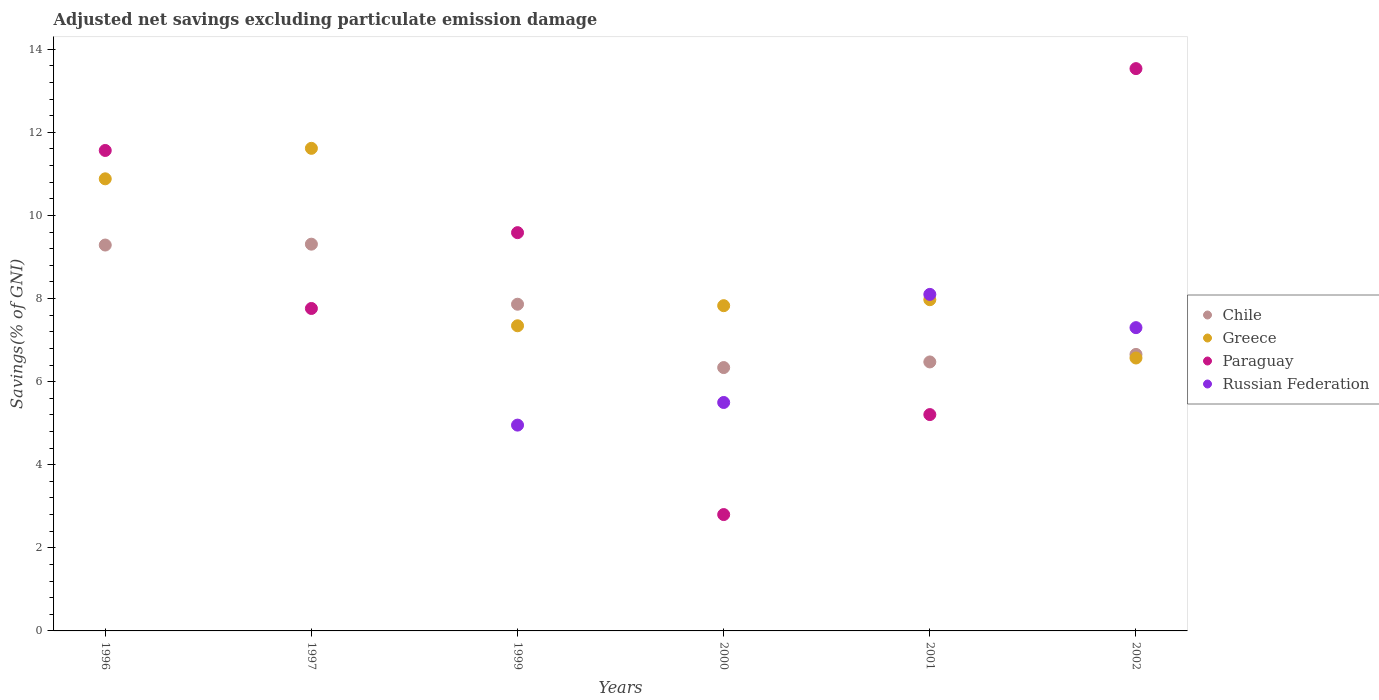Is the number of dotlines equal to the number of legend labels?
Keep it short and to the point. No. What is the adjusted net savings in Paraguay in 2000?
Your response must be concise. 2.8. Across all years, what is the maximum adjusted net savings in Paraguay?
Your answer should be very brief. 13.53. Across all years, what is the minimum adjusted net savings in Russian Federation?
Make the answer very short. 0. What is the total adjusted net savings in Greece in the graph?
Keep it short and to the point. 52.21. What is the difference between the adjusted net savings in Paraguay in 1996 and that in 2000?
Your answer should be very brief. 8.76. What is the difference between the adjusted net savings in Russian Federation in 1997 and the adjusted net savings in Chile in 2000?
Give a very brief answer. -6.34. What is the average adjusted net savings in Chile per year?
Make the answer very short. 7.65. In the year 1997, what is the difference between the adjusted net savings in Paraguay and adjusted net savings in Greece?
Your answer should be very brief. -3.85. What is the ratio of the adjusted net savings in Chile in 1996 to that in 1999?
Give a very brief answer. 1.18. Is the adjusted net savings in Paraguay in 1996 less than that in 2000?
Ensure brevity in your answer.  No. Is the difference between the adjusted net savings in Paraguay in 1997 and 2002 greater than the difference between the adjusted net savings in Greece in 1997 and 2002?
Give a very brief answer. No. What is the difference between the highest and the second highest adjusted net savings in Russian Federation?
Your answer should be compact. 0.8. What is the difference between the highest and the lowest adjusted net savings in Russian Federation?
Provide a short and direct response. 8.1. In how many years, is the adjusted net savings in Russian Federation greater than the average adjusted net savings in Russian Federation taken over all years?
Offer a very short reply. 4. Is the sum of the adjusted net savings in Paraguay in 1996 and 1997 greater than the maximum adjusted net savings in Greece across all years?
Your answer should be compact. Yes. Does the adjusted net savings in Chile monotonically increase over the years?
Ensure brevity in your answer.  No. Is the adjusted net savings in Chile strictly greater than the adjusted net savings in Greece over the years?
Make the answer very short. No. Is the adjusted net savings in Paraguay strictly less than the adjusted net savings in Chile over the years?
Your answer should be compact. No. How many dotlines are there?
Your answer should be very brief. 4. What is the difference between two consecutive major ticks on the Y-axis?
Offer a terse response. 2. Are the values on the major ticks of Y-axis written in scientific E-notation?
Offer a terse response. No. Does the graph contain any zero values?
Your answer should be very brief. Yes. Does the graph contain grids?
Your answer should be compact. No. Where does the legend appear in the graph?
Make the answer very short. Center right. How many legend labels are there?
Offer a terse response. 4. What is the title of the graph?
Keep it short and to the point. Adjusted net savings excluding particulate emission damage. Does "Bulgaria" appear as one of the legend labels in the graph?
Provide a short and direct response. No. What is the label or title of the Y-axis?
Your response must be concise. Savings(% of GNI). What is the Savings(% of GNI) of Chile in 1996?
Provide a short and direct response. 9.29. What is the Savings(% of GNI) in Greece in 1996?
Offer a terse response. 10.88. What is the Savings(% of GNI) in Paraguay in 1996?
Give a very brief answer. 11.56. What is the Savings(% of GNI) of Russian Federation in 1996?
Make the answer very short. 0. What is the Savings(% of GNI) of Chile in 1997?
Make the answer very short. 9.31. What is the Savings(% of GNI) of Greece in 1997?
Provide a succinct answer. 11.62. What is the Savings(% of GNI) of Paraguay in 1997?
Your response must be concise. 7.76. What is the Savings(% of GNI) in Russian Federation in 1997?
Ensure brevity in your answer.  0. What is the Savings(% of GNI) in Chile in 1999?
Give a very brief answer. 7.86. What is the Savings(% of GNI) of Greece in 1999?
Offer a terse response. 7.34. What is the Savings(% of GNI) in Paraguay in 1999?
Your answer should be very brief. 9.59. What is the Savings(% of GNI) in Russian Federation in 1999?
Your response must be concise. 4.95. What is the Savings(% of GNI) of Chile in 2000?
Provide a short and direct response. 6.34. What is the Savings(% of GNI) of Greece in 2000?
Make the answer very short. 7.83. What is the Savings(% of GNI) of Paraguay in 2000?
Keep it short and to the point. 2.8. What is the Savings(% of GNI) in Russian Federation in 2000?
Offer a terse response. 5.5. What is the Savings(% of GNI) in Chile in 2001?
Offer a very short reply. 6.47. What is the Savings(% of GNI) of Greece in 2001?
Give a very brief answer. 7.97. What is the Savings(% of GNI) of Paraguay in 2001?
Provide a short and direct response. 5.21. What is the Savings(% of GNI) of Russian Federation in 2001?
Your answer should be compact. 8.1. What is the Savings(% of GNI) in Chile in 2002?
Give a very brief answer. 6.66. What is the Savings(% of GNI) in Greece in 2002?
Offer a terse response. 6.57. What is the Savings(% of GNI) in Paraguay in 2002?
Offer a terse response. 13.53. What is the Savings(% of GNI) in Russian Federation in 2002?
Your answer should be compact. 7.3. Across all years, what is the maximum Savings(% of GNI) in Chile?
Keep it short and to the point. 9.31. Across all years, what is the maximum Savings(% of GNI) of Greece?
Your answer should be very brief. 11.62. Across all years, what is the maximum Savings(% of GNI) in Paraguay?
Your answer should be compact. 13.53. Across all years, what is the maximum Savings(% of GNI) of Russian Federation?
Provide a short and direct response. 8.1. Across all years, what is the minimum Savings(% of GNI) of Chile?
Offer a terse response. 6.34. Across all years, what is the minimum Savings(% of GNI) of Greece?
Ensure brevity in your answer.  6.57. Across all years, what is the minimum Savings(% of GNI) in Paraguay?
Provide a succinct answer. 2.8. What is the total Savings(% of GNI) of Chile in the graph?
Keep it short and to the point. 45.93. What is the total Savings(% of GNI) of Greece in the graph?
Make the answer very short. 52.21. What is the total Savings(% of GNI) of Paraguay in the graph?
Keep it short and to the point. 50.45. What is the total Savings(% of GNI) of Russian Federation in the graph?
Give a very brief answer. 25.85. What is the difference between the Savings(% of GNI) in Chile in 1996 and that in 1997?
Offer a terse response. -0.02. What is the difference between the Savings(% of GNI) of Greece in 1996 and that in 1997?
Offer a very short reply. -0.73. What is the difference between the Savings(% of GNI) of Paraguay in 1996 and that in 1997?
Make the answer very short. 3.8. What is the difference between the Savings(% of GNI) of Chile in 1996 and that in 1999?
Your response must be concise. 1.42. What is the difference between the Savings(% of GNI) in Greece in 1996 and that in 1999?
Offer a very short reply. 3.54. What is the difference between the Savings(% of GNI) in Paraguay in 1996 and that in 1999?
Offer a terse response. 1.98. What is the difference between the Savings(% of GNI) in Chile in 1996 and that in 2000?
Give a very brief answer. 2.95. What is the difference between the Savings(% of GNI) of Greece in 1996 and that in 2000?
Keep it short and to the point. 3.05. What is the difference between the Savings(% of GNI) of Paraguay in 1996 and that in 2000?
Give a very brief answer. 8.76. What is the difference between the Savings(% of GNI) in Chile in 1996 and that in 2001?
Your answer should be very brief. 2.81. What is the difference between the Savings(% of GNI) in Greece in 1996 and that in 2001?
Offer a very short reply. 2.91. What is the difference between the Savings(% of GNI) of Paraguay in 1996 and that in 2001?
Offer a very short reply. 6.36. What is the difference between the Savings(% of GNI) of Chile in 1996 and that in 2002?
Give a very brief answer. 2.63. What is the difference between the Savings(% of GNI) of Greece in 1996 and that in 2002?
Your answer should be compact. 4.31. What is the difference between the Savings(% of GNI) of Paraguay in 1996 and that in 2002?
Your response must be concise. -1.97. What is the difference between the Savings(% of GNI) in Chile in 1997 and that in 1999?
Give a very brief answer. 1.45. What is the difference between the Savings(% of GNI) of Greece in 1997 and that in 1999?
Keep it short and to the point. 4.27. What is the difference between the Savings(% of GNI) in Paraguay in 1997 and that in 1999?
Give a very brief answer. -1.83. What is the difference between the Savings(% of GNI) of Chile in 1997 and that in 2000?
Provide a short and direct response. 2.97. What is the difference between the Savings(% of GNI) in Greece in 1997 and that in 2000?
Offer a terse response. 3.79. What is the difference between the Savings(% of GNI) in Paraguay in 1997 and that in 2000?
Make the answer very short. 4.96. What is the difference between the Savings(% of GNI) of Chile in 1997 and that in 2001?
Provide a short and direct response. 2.83. What is the difference between the Savings(% of GNI) of Greece in 1997 and that in 2001?
Provide a short and direct response. 3.64. What is the difference between the Savings(% of GNI) in Paraguay in 1997 and that in 2001?
Provide a short and direct response. 2.55. What is the difference between the Savings(% of GNI) of Chile in 1997 and that in 2002?
Give a very brief answer. 2.65. What is the difference between the Savings(% of GNI) of Greece in 1997 and that in 2002?
Your response must be concise. 5.05. What is the difference between the Savings(% of GNI) in Paraguay in 1997 and that in 2002?
Offer a terse response. -5.77. What is the difference between the Savings(% of GNI) in Chile in 1999 and that in 2000?
Provide a short and direct response. 1.52. What is the difference between the Savings(% of GNI) of Greece in 1999 and that in 2000?
Ensure brevity in your answer.  -0.48. What is the difference between the Savings(% of GNI) in Paraguay in 1999 and that in 2000?
Your answer should be compact. 6.79. What is the difference between the Savings(% of GNI) of Russian Federation in 1999 and that in 2000?
Your answer should be compact. -0.54. What is the difference between the Savings(% of GNI) in Chile in 1999 and that in 2001?
Offer a very short reply. 1.39. What is the difference between the Savings(% of GNI) in Greece in 1999 and that in 2001?
Offer a very short reply. -0.63. What is the difference between the Savings(% of GNI) of Paraguay in 1999 and that in 2001?
Your response must be concise. 4.38. What is the difference between the Savings(% of GNI) of Russian Federation in 1999 and that in 2001?
Your response must be concise. -3.15. What is the difference between the Savings(% of GNI) in Chile in 1999 and that in 2002?
Offer a very short reply. 1.21. What is the difference between the Savings(% of GNI) in Greece in 1999 and that in 2002?
Your answer should be very brief. 0.78. What is the difference between the Savings(% of GNI) in Paraguay in 1999 and that in 2002?
Keep it short and to the point. -3.95. What is the difference between the Savings(% of GNI) in Russian Federation in 1999 and that in 2002?
Make the answer very short. -2.35. What is the difference between the Savings(% of GNI) in Chile in 2000 and that in 2001?
Offer a very short reply. -0.14. What is the difference between the Savings(% of GNI) of Greece in 2000 and that in 2001?
Keep it short and to the point. -0.14. What is the difference between the Savings(% of GNI) of Paraguay in 2000 and that in 2001?
Ensure brevity in your answer.  -2.41. What is the difference between the Savings(% of GNI) in Russian Federation in 2000 and that in 2001?
Your answer should be very brief. -2.6. What is the difference between the Savings(% of GNI) of Chile in 2000 and that in 2002?
Provide a short and direct response. -0.32. What is the difference between the Savings(% of GNI) of Greece in 2000 and that in 2002?
Ensure brevity in your answer.  1.26. What is the difference between the Savings(% of GNI) in Paraguay in 2000 and that in 2002?
Your answer should be very brief. -10.73. What is the difference between the Savings(% of GNI) of Russian Federation in 2000 and that in 2002?
Provide a short and direct response. -1.8. What is the difference between the Savings(% of GNI) of Chile in 2001 and that in 2002?
Ensure brevity in your answer.  -0.18. What is the difference between the Savings(% of GNI) of Greece in 2001 and that in 2002?
Your response must be concise. 1.4. What is the difference between the Savings(% of GNI) in Paraguay in 2001 and that in 2002?
Make the answer very short. -8.33. What is the difference between the Savings(% of GNI) in Russian Federation in 2001 and that in 2002?
Provide a succinct answer. 0.8. What is the difference between the Savings(% of GNI) in Chile in 1996 and the Savings(% of GNI) in Greece in 1997?
Make the answer very short. -2.33. What is the difference between the Savings(% of GNI) in Chile in 1996 and the Savings(% of GNI) in Paraguay in 1997?
Your answer should be compact. 1.53. What is the difference between the Savings(% of GNI) of Greece in 1996 and the Savings(% of GNI) of Paraguay in 1997?
Make the answer very short. 3.12. What is the difference between the Savings(% of GNI) of Chile in 1996 and the Savings(% of GNI) of Greece in 1999?
Make the answer very short. 1.94. What is the difference between the Savings(% of GNI) in Chile in 1996 and the Savings(% of GNI) in Paraguay in 1999?
Offer a terse response. -0.3. What is the difference between the Savings(% of GNI) in Chile in 1996 and the Savings(% of GNI) in Russian Federation in 1999?
Offer a terse response. 4.33. What is the difference between the Savings(% of GNI) of Greece in 1996 and the Savings(% of GNI) of Paraguay in 1999?
Offer a terse response. 1.3. What is the difference between the Savings(% of GNI) in Greece in 1996 and the Savings(% of GNI) in Russian Federation in 1999?
Offer a terse response. 5.93. What is the difference between the Savings(% of GNI) in Paraguay in 1996 and the Savings(% of GNI) in Russian Federation in 1999?
Give a very brief answer. 6.61. What is the difference between the Savings(% of GNI) of Chile in 1996 and the Savings(% of GNI) of Greece in 2000?
Your answer should be very brief. 1.46. What is the difference between the Savings(% of GNI) of Chile in 1996 and the Savings(% of GNI) of Paraguay in 2000?
Offer a terse response. 6.49. What is the difference between the Savings(% of GNI) in Chile in 1996 and the Savings(% of GNI) in Russian Federation in 2000?
Offer a terse response. 3.79. What is the difference between the Savings(% of GNI) in Greece in 1996 and the Savings(% of GNI) in Paraguay in 2000?
Offer a very short reply. 8.08. What is the difference between the Savings(% of GNI) in Greece in 1996 and the Savings(% of GNI) in Russian Federation in 2000?
Your response must be concise. 5.38. What is the difference between the Savings(% of GNI) of Paraguay in 1996 and the Savings(% of GNI) of Russian Federation in 2000?
Your answer should be compact. 6.07. What is the difference between the Savings(% of GNI) of Chile in 1996 and the Savings(% of GNI) of Greece in 2001?
Your answer should be compact. 1.32. What is the difference between the Savings(% of GNI) in Chile in 1996 and the Savings(% of GNI) in Paraguay in 2001?
Keep it short and to the point. 4.08. What is the difference between the Savings(% of GNI) in Chile in 1996 and the Savings(% of GNI) in Russian Federation in 2001?
Offer a terse response. 1.19. What is the difference between the Savings(% of GNI) of Greece in 1996 and the Savings(% of GNI) of Paraguay in 2001?
Your answer should be very brief. 5.67. What is the difference between the Savings(% of GNI) in Greece in 1996 and the Savings(% of GNI) in Russian Federation in 2001?
Provide a short and direct response. 2.78. What is the difference between the Savings(% of GNI) in Paraguay in 1996 and the Savings(% of GNI) in Russian Federation in 2001?
Provide a succinct answer. 3.46. What is the difference between the Savings(% of GNI) in Chile in 1996 and the Savings(% of GNI) in Greece in 2002?
Your answer should be very brief. 2.72. What is the difference between the Savings(% of GNI) of Chile in 1996 and the Savings(% of GNI) of Paraguay in 2002?
Provide a short and direct response. -4.25. What is the difference between the Savings(% of GNI) of Chile in 1996 and the Savings(% of GNI) of Russian Federation in 2002?
Ensure brevity in your answer.  1.99. What is the difference between the Savings(% of GNI) in Greece in 1996 and the Savings(% of GNI) in Paraguay in 2002?
Provide a succinct answer. -2.65. What is the difference between the Savings(% of GNI) of Greece in 1996 and the Savings(% of GNI) of Russian Federation in 2002?
Keep it short and to the point. 3.58. What is the difference between the Savings(% of GNI) of Paraguay in 1996 and the Savings(% of GNI) of Russian Federation in 2002?
Ensure brevity in your answer.  4.26. What is the difference between the Savings(% of GNI) of Chile in 1997 and the Savings(% of GNI) of Greece in 1999?
Your answer should be very brief. 1.96. What is the difference between the Savings(% of GNI) in Chile in 1997 and the Savings(% of GNI) in Paraguay in 1999?
Your answer should be compact. -0.28. What is the difference between the Savings(% of GNI) in Chile in 1997 and the Savings(% of GNI) in Russian Federation in 1999?
Your answer should be very brief. 4.35. What is the difference between the Savings(% of GNI) in Greece in 1997 and the Savings(% of GNI) in Paraguay in 1999?
Your answer should be very brief. 2.03. What is the difference between the Savings(% of GNI) in Greece in 1997 and the Savings(% of GNI) in Russian Federation in 1999?
Keep it short and to the point. 6.66. What is the difference between the Savings(% of GNI) in Paraguay in 1997 and the Savings(% of GNI) in Russian Federation in 1999?
Offer a terse response. 2.81. What is the difference between the Savings(% of GNI) in Chile in 1997 and the Savings(% of GNI) in Greece in 2000?
Your response must be concise. 1.48. What is the difference between the Savings(% of GNI) of Chile in 1997 and the Savings(% of GNI) of Paraguay in 2000?
Provide a short and direct response. 6.51. What is the difference between the Savings(% of GNI) in Chile in 1997 and the Savings(% of GNI) in Russian Federation in 2000?
Give a very brief answer. 3.81. What is the difference between the Savings(% of GNI) in Greece in 1997 and the Savings(% of GNI) in Paraguay in 2000?
Give a very brief answer. 8.81. What is the difference between the Savings(% of GNI) of Greece in 1997 and the Savings(% of GNI) of Russian Federation in 2000?
Provide a succinct answer. 6.12. What is the difference between the Savings(% of GNI) of Paraguay in 1997 and the Savings(% of GNI) of Russian Federation in 2000?
Offer a terse response. 2.26. What is the difference between the Savings(% of GNI) in Chile in 1997 and the Savings(% of GNI) in Greece in 2001?
Give a very brief answer. 1.34. What is the difference between the Savings(% of GNI) of Chile in 1997 and the Savings(% of GNI) of Paraguay in 2001?
Make the answer very short. 4.1. What is the difference between the Savings(% of GNI) in Chile in 1997 and the Savings(% of GNI) in Russian Federation in 2001?
Make the answer very short. 1.21. What is the difference between the Savings(% of GNI) of Greece in 1997 and the Savings(% of GNI) of Paraguay in 2001?
Offer a terse response. 6.41. What is the difference between the Savings(% of GNI) in Greece in 1997 and the Savings(% of GNI) in Russian Federation in 2001?
Provide a succinct answer. 3.52. What is the difference between the Savings(% of GNI) of Paraguay in 1997 and the Savings(% of GNI) of Russian Federation in 2001?
Your answer should be compact. -0.34. What is the difference between the Savings(% of GNI) in Chile in 1997 and the Savings(% of GNI) in Greece in 2002?
Offer a terse response. 2.74. What is the difference between the Savings(% of GNI) of Chile in 1997 and the Savings(% of GNI) of Paraguay in 2002?
Make the answer very short. -4.23. What is the difference between the Savings(% of GNI) in Chile in 1997 and the Savings(% of GNI) in Russian Federation in 2002?
Ensure brevity in your answer.  2.01. What is the difference between the Savings(% of GNI) in Greece in 1997 and the Savings(% of GNI) in Paraguay in 2002?
Your answer should be compact. -1.92. What is the difference between the Savings(% of GNI) in Greece in 1997 and the Savings(% of GNI) in Russian Federation in 2002?
Offer a terse response. 4.32. What is the difference between the Savings(% of GNI) of Paraguay in 1997 and the Savings(% of GNI) of Russian Federation in 2002?
Your answer should be compact. 0.46. What is the difference between the Savings(% of GNI) of Chile in 1999 and the Savings(% of GNI) of Greece in 2000?
Provide a succinct answer. 0.04. What is the difference between the Savings(% of GNI) of Chile in 1999 and the Savings(% of GNI) of Paraguay in 2000?
Your response must be concise. 5.06. What is the difference between the Savings(% of GNI) in Chile in 1999 and the Savings(% of GNI) in Russian Federation in 2000?
Give a very brief answer. 2.36. What is the difference between the Savings(% of GNI) in Greece in 1999 and the Savings(% of GNI) in Paraguay in 2000?
Offer a very short reply. 4.54. What is the difference between the Savings(% of GNI) in Greece in 1999 and the Savings(% of GNI) in Russian Federation in 2000?
Make the answer very short. 1.85. What is the difference between the Savings(% of GNI) of Paraguay in 1999 and the Savings(% of GNI) of Russian Federation in 2000?
Offer a very short reply. 4.09. What is the difference between the Savings(% of GNI) in Chile in 1999 and the Savings(% of GNI) in Greece in 2001?
Your answer should be compact. -0.11. What is the difference between the Savings(% of GNI) in Chile in 1999 and the Savings(% of GNI) in Paraguay in 2001?
Provide a short and direct response. 2.66. What is the difference between the Savings(% of GNI) in Chile in 1999 and the Savings(% of GNI) in Russian Federation in 2001?
Your answer should be very brief. -0.24. What is the difference between the Savings(% of GNI) of Greece in 1999 and the Savings(% of GNI) of Paraguay in 2001?
Give a very brief answer. 2.14. What is the difference between the Savings(% of GNI) of Greece in 1999 and the Savings(% of GNI) of Russian Federation in 2001?
Make the answer very short. -0.76. What is the difference between the Savings(% of GNI) of Paraguay in 1999 and the Savings(% of GNI) of Russian Federation in 2001?
Your response must be concise. 1.49. What is the difference between the Savings(% of GNI) of Chile in 1999 and the Savings(% of GNI) of Greece in 2002?
Provide a short and direct response. 1.29. What is the difference between the Savings(% of GNI) of Chile in 1999 and the Savings(% of GNI) of Paraguay in 2002?
Your answer should be very brief. -5.67. What is the difference between the Savings(% of GNI) of Chile in 1999 and the Savings(% of GNI) of Russian Federation in 2002?
Offer a very short reply. 0.56. What is the difference between the Savings(% of GNI) of Greece in 1999 and the Savings(% of GNI) of Paraguay in 2002?
Offer a terse response. -6.19. What is the difference between the Savings(% of GNI) in Greece in 1999 and the Savings(% of GNI) in Russian Federation in 2002?
Ensure brevity in your answer.  0.05. What is the difference between the Savings(% of GNI) in Paraguay in 1999 and the Savings(% of GNI) in Russian Federation in 2002?
Your answer should be compact. 2.29. What is the difference between the Savings(% of GNI) in Chile in 2000 and the Savings(% of GNI) in Greece in 2001?
Keep it short and to the point. -1.63. What is the difference between the Savings(% of GNI) of Chile in 2000 and the Savings(% of GNI) of Paraguay in 2001?
Make the answer very short. 1.13. What is the difference between the Savings(% of GNI) of Chile in 2000 and the Savings(% of GNI) of Russian Federation in 2001?
Offer a very short reply. -1.76. What is the difference between the Savings(% of GNI) in Greece in 2000 and the Savings(% of GNI) in Paraguay in 2001?
Your response must be concise. 2.62. What is the difference between the Savings(% of GNI) of Greece in 2000 and the Savings(% of GNI) of Russian Federation in 2001?
Keep it short and to the point. -0.27. What is the difference between the Savings(% of GNI) in Paraguay in 2000 and the Savings(% of GNI) in Russian Federation in 2001?
Your answer should be very brief. -5.3. What is the difference between the Savings(% of GNI) of Chile in 2000 and the Savings(% of GNI) of Greece in 2002?
Give a very brief answer. -0.23. What is the difference between the Savings(% of GNI) of Chile in 2000 and the Savings(% of GNI) of Paraguay in 2002?
Provide a short and direct response. -7.2. What is the difference between the Savings(% of GNI) of Chile in 2000 and the Savings(% of GNI) of Russian Federation in 2002?
Keep it short and to the point. -0.96. What is the difference between the Savings(% of GNI) in Greece in 2000 and the Savings(% of GNI) in Paraguay in 2002?
Make the answer very short. -5.71. What is the difference between the Savings(% of GNI) of Greece in 2000 and the Savings(% of GNI) of Russian Federation in 2002?
Your answer should be compact. 0.53. What is the difference between the Savings(% of GNI) in Paraguay in 2000 and the Savings(% of GNI) in Russian Federation in 2002?
Your answer should be very brief. -4.5. What is the difference between the Savings(% of GNI) in Chile in 2001 and the Savings(% of GNI) in Greece in 2002?
Offer a terse response. -0.09. What is the difference between the Savings(% of GNI) of Chile in 2001 and the Savings(% of GNI) of Paraguay in 2002?
Offer a very short reply. -7.06. What is the difference between the Savings(% of GNI) of Chile in 2001 and the Savings(% of GNI) of Russian Federation in 2002?
Give a very brief answer. -0.83. What is the difference between the Savings(% of GNI) of Greece in 2001 and the Savings(% of GNI) of Paraguay in 2002?
Provide a succinct answer. -5.56. What is the difference between the Savings(% of GNI) in Greece in 2001 and the Savings(% of GNI) in Russian Federation in 2002?
Give a very brief answer. 0.67. What is the difference between the Savings(% of GNI) of Paraguay in 2001 and the Savings(% of GNI) of Russian Federation in 2002?
Ensure brevity in your answer.  -2.09. What is the average Savings(% of GNI) of Chile per year?
Keep it short and to the point. 7.65. What is the average Savings(% of GNI) in Greece per year?
Provide a short and direct response. 8.7. What is the average Savings(% of GNI) in Paraguay per year?
Provide a succinct answer. 8.41. What is the average Savings(% of GNI) in Russian Federation per year?
Provide a succinct answer. 4.31. In the year 1996, what is the difference between the Savings(% of GNI) of Chile and Savings(% of GNI) of Greece?
Make the answer very short. -1.59. In the year 1996, what is the difference between the Savings(% of GNI) in Chile and Savings(% of GNI) in Paraguay?
Provide a succinct answer. -2.28. In the year 1996, what is the difference between the Savings(% of GNI) of Greece and Savings(% of GNI) of Paraguay?
Make the answer very short. -0.68. In the year 1997, what is the difference between the Savings(% of GNI) of Chile and Savings(% of GNI) of Greece?
Your answer should be compact. -2.31. In the year 1997, what is the difference between the Savings(% of GNI) of Chile and Savings(% of GNI) of Paraguay?
Your answer should be compact. 1.55. In the year 1997, what is the difference between the Savings(% of GNI) of Greece and Savings(% of GNI) of Paraguay?
Ensure brevity in your answer.  3.85. In the year 1999, what is the difference between the Savings(% of GNI) in Chile and Savings(% of GNI) in Greece?
Your answer should be very brief. 0.52. In the year 1999, what is the difference between the Savings(% of GNI) of Chile and Savings(% of GNI) of Paraguay?
Offer a terse response. -1.72. In the year 1999, what is the difference between the Savings(% of GNI) in Chile and Savings(% of GNI) in Russian Federation?
Your response must be concise. 2.91. In the year 1999, what is the difference between the Savings(% of GNI) in Greece and Savings(% of GNI) in Paraguay?
Make the answer very short. -2.24. In the year 1999, what is the difference between the Savings(% of GNI) in Greece and Savings(% of GNI) in Russian Federation?
Offer a very short reply. 2.39. In the year 1999, what is the difference between the Savings(% of GNI) of Paraguay and Savings(% of GNI) of Russian Federation?
Give a very brief answer. 4.63. In the year 2000, what is the difference between the Savings(% of GNI) in Chile and Savings(% of GNI) in Greece?
Provide a short and direct response. -1.49. In the year 2000, what is the difference between the Savings(% of GNI) in Chile and Savings(% of GNI) in Paraguay?
Your answer should be very brief. 3.54. In the year 2000, what is the difference between the Savings(% of GNI) in Chile and Savings(% of GNI) in Russian Federation?
Your answer should be compact. 0.84. In the year 2000, what is the difference between the Savings(% of GNI) of Greece and Savings(% of GNI) of Paraguay?
Ensure brevity in your answer.  5.03. In the year 2000, what is the difference between the Savings(% of GNI) of Greece and Savings(% of GNI) of Russian Federation?
Provide a short and direct response. 2.33. In the year 2000, what is the difference between the Savings(% of GNI) of Paraguay and Savings(% of GNI) of Russian Federation?
Offer a very short reply. -2.7. In the year 2001, what is the difference between the Savings(% of GNI) in Chile and Savings(% of GNI) in Greece?
Ensure brevity in your answer.  -1.5. In the year 2001, what is the difference between the Savings(% of GNI) of Chile and Savings(% of GNI) of Paraguay?
Your answer should be compact. 1.27. In the year 2001, what is the difference between the Savings(% of GNI) of Chile and Savings(% of GNI) of Russian Federation?
Offer a very short reply. -1.63. In the year 2001, what is the difference between the Savings(% of GNI) in Greece and Savings(% of GNI) in Paraguay?
Your answer should be compact. 2.76. In the year 2001, what is the difference between the Savings(% of GNI) in Greece and Savings(% of GNI) in Russian Federation?
Keep it short and to the point. -0.13. In the year 2001, what is the difference between the Savings(% of GNI) in Paraguay and Savings(% of GNI) in Russian Federation?
Offer a terse response. -2.89. In the year 2002, what is the difference between the Savings(% of GNI) in Chile and Savings(% of GNI) in Greece?
Offer a terse response. 0.09. In the year 2002, what is the difference between the Savings(% of GNI) of Chile and Savings(% of GNI) of Paraguay?
Your response must be concise. -6.88. In the year 2002, what is the difference between the Savings(% of GNI) in Chile and Savings(% of GNI) in Russian Federation?
Give a very brief answer. -0.64. In the year 2002, what is the difference between the Savings(% of GNI) of Greece and Savings(% of GNI) of Paraguay?
Your response must be concise. -6.96. In the year 2002, what is the difference between the Savings(% of GNI) of Greece and Savings(% of GNI) of Russian Federation?
Keep it short and to the point. -0.73. In the year 2002, what is the difference between the Savings(% of GNI) of Paraguay and Savings(% of GNI) of Russian Federation?
Provide a short and direct response. 6.23. What is the ratio of the Savings(% of GNI) in Greece in 1996 to that in 1997?
Your answer should be very brief. 0.94. What is the ratio of the Savings(% of GNI) of Paraguay in 1996 to that in 1997?
Your response must be concise. 1.49. What is the ratio of the Savings(% of GNI) in Chile in 1996 to that in 1999?
Keep it short and to the point. 1.18. What is the ratio of the Savings(% of GNI) of Greece in 1996 to that in 1999?
Provide a short and direct response. 1.48. What is the ratio of the Savings(% of GNI) of Paraguay in 1996 to that in 1999?
Your answer should be very brief. 1.21. What is the ratio of the Savings(% of GNI) of Chile in 1996 to that in 2000?
Give a very brief answer. 1.47. What is the ratio of the Savings(% of GNI) of Greece in 1996 to that in 2000?
Ensure brevity in your answer.  1.39. What is the ratio of the Savings(% of GNI) in Paraguay in 1996 to that in 2000?
Your answer should be very brief. 4.13. What is the ratio of the Savings(% of GNI) of Chile in 1996 to that in 2001?
Provide a succinct answer. 1.43. What is the ratio of the Savings(% of GNI) of Greece in 1996 to that in 2001?
Offer a very short reply. 1.36. What is the ratio of the Savings(% of GNI) in Paraguay in 1996 to that in 2001?
Keep it short and to the point. 2.22. What is the ratio of the Savings(% of GNI) in Chile in 1996 to that in 2002?
Your answer should be very brief. 1.4. What is the ratio of the Savings(% of GNI) of Greece in 1996 to that in 2002?
Make the answer very short. 1.66. What is the ratio of the Savings(% of GNI) of Paraguay in 1996 to that in 2002?
Ensure brevity in your answer.  0.85. What is the ratio of the Savings(% of GNI) in Chile in 1997 to that in 1999?
Give a very brief answer. 1.18. What is the ratio of the Savings(% of GNI) in Greece in 1997 to that in 1999?
Offer a very short reply. 1.58. What is the ratio of the Savings(% of GNI) in Paraguay in 1997 to that in 1999?
Provide a succinct answer. 0.81. What is the ratio of the Savings(% of GNI) in Chile in 1997 to that in 2000?
Offer a terse response. 1.47. What is the ratio of the Savings(% of GNI) of Greece in 1997 to that in 2000?
Make the answer very short. 1.48. What is the ratio of the Savings(% of GNI) of Paraguay in 1997 to that in 2000?
Your answer should be compact. 2.77. What is the ratio of the Savings(% of GNI) of Chile in 1997 to that in 2001?
Give a very brief answer. 1.44. What is the ratio of the Savings(% of GNI) in Greece in 1997 to that in 2001?
Make the answer very short. 1.46. What is the ratio of the Savings(% of GNI) of Paraguay in 1997 to that in 2001?
Give a very brief answer. 1.49. What is the ratio of the Savings(% of GNI) in Chile in 1997 to that in 2002?
Make the answer very short. 1.4. What is the ratio of the Savings(% of GNI) of Greece in 1997 to that in 2002?
Offer a very short reply. 1.77. What is the ratio of the Savings(% of GNI) of Paraguay in 1997 to that in 2002?
Offer a very short reply. 0.57. What is the ratio of the Savings(% of GNI) of Chile in 1999 to that in 2000?
Offer a terse response. 1.24. What is the ratio of the Savings(% of GNI) in Greece in 1999 to that in 2000?
Your answer should be compact. 0.94. What is the ratio of the Savings(% of GNI) in Paraguay in 1999 to that in 2000?
Ensure brevity in your answer.  3.42. What is the ratio of the Savings(% of GNI) of Russian Federation in 1999 to that in 2000?
Ensure brevity in your answer.  0.9. What is the ratio of the Savings(% of GNI) of Chile in 1999 to that in 2001?
Provide a short and direct response. 1.21. What is the ratio of the Savings(% of GNI) in Greece in 1999 to that in 2001?
Offer a very short reply. 0.92. What is the ratio of the Savings(% of GNI) of Paraguay in 1999 to that in 2001?
Offer a very short reply. 1.84. What is the ratio of the Savings(% of GNI) of Russian Federation in 1999 to that in 2001?
Your response must be concise. 0.61. What is the ratio of the Savings(% of GNI) of Chile in 1999 to that in 2002?
Your response must be concise. 1.18. What is the ratio of the Savings(% of GNI) in Greece in 1999 to that in 2002?
Your answer should be compact. 1.12. What is the ratio of the Savings(% of GNI) of Paraguay in 1999 to that in 2002?
Provide a short and direct response. 0.71. What is the ratio of the Savings(% of GNI) of Russian Federation in 1999 to that in 2002?
Provide a short and direct response. 0.68. What is the ratio of the Savings(% of GNI) in Chile in 2000 to that in 2001?
Provide a short and direct response. 0.98. What is the ratio of the Savings(% of GNI) in Greece in 2000 to that in 2001?
Your answer should be compact. 0.98. What is the ratio of the Savings(% of GNI) in Paraguay in 2000 to that in 2001?
Provide a succinct answer. 0.54. What is the ratio of the Savings(% of GNI) of Russian Federation in 2000 to that in 2001?
Your answer should be very brief. 0.68. What is the ratio of the Savings(% of GNI) in Chile in 2000 to that in 2002?
Provide a succinct answer. 0.95. What is the ratio of the Savings(% of GNI) in Greece in 2000 to that in 2002?
Give a very brief answer. 1.19. What is the ratio of the Savings(% of GNI) of Paraguay in 2000 to that in 2002?
Offer a very short reply. 0.21. What is the ratio of the Savings(% of GNI) in Russian Federation in 2000 to that in 2002?
Make the answer very short. 0.75. What is the ratio of the Savings(% of GNI) in Chile in 2001 to that in 2002?
Your answer should be compact. 0.97. What is the ratio of the Savings(% of GNI) of Greece in 2001 to that in 2002?
Your response must be concise. 1.21. What is the ratio of the Savings(% of GNI) of Paraguay in 2001 to that in 2002?
Your answer should be very brief. 0.38. What is the ratio of the Savings(% of GNI) in Russian Federation in 2001 to that in 2002?
Offer a terse response. 1.11. What is the difference between the highest and the second highest Savings(% of GNI) of Chile?
Keep it short and to the point. 0.02. What is the difference between the highest and the second highest Savings(% of GNI) of Greece?
Offer a very short reply. 0.73. What is the difference between the highest and the second highest Savings(% of GNI) of Paraguay?
Your answer should be very brief. 1.97. What is the difference between the highest and the second highest Savings(% of GNI) in Russian Federation?
Make the answer very short. 0.8. What is the difference between the highest and the lowest Savings(% of GNI) in Chile?
Ensure brevity in your answer.  2.97. What is the difference between the highest and the lowest Savings(% of GNI) of Greece?
Provide a short and direct response. 5.05. What is the difference between the highest and the lowest Savings(% of GNI) of Paraguay?
Provide a succinct answer. 10.73. 